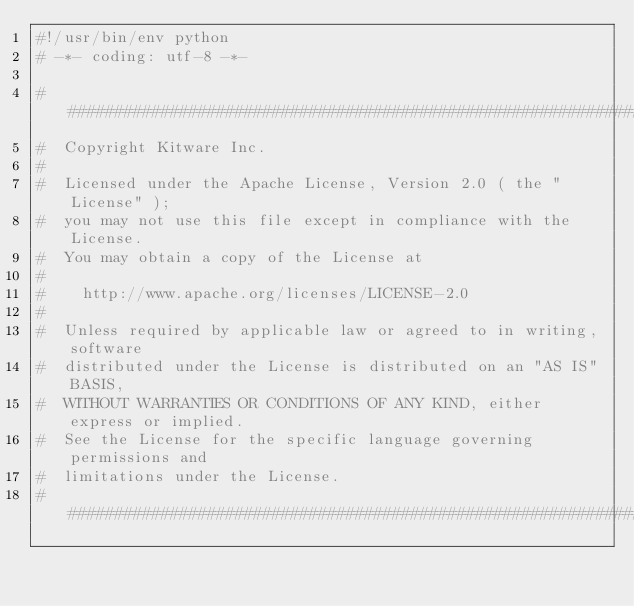<code> <loc_0><loc_0><loc_500><loc_500><_Python_>#!/usr/bin/env python
# -*- coding: utf-8 -*-

###############################################################################
#  Copyright Kitware Inc.
#
#  Licensed under the Apache License, Version 2.0 ( the "License" );
#  you may not use this file except in compliance with the License.
#  You may obtain a copy of the License at
#
#    http://www.apache.org/licenses/LICENSE-2.0
#
#  Unless required by applicable law or agreed to in writing, software
#  distributed under the License is distributed on an "AS IS" BASIS,
#  WITHOUT WARRANTIES OR CONDITIONS OF ANY KIND, either express or implied.
#  See the License for the specific language governing permissions and
#  limitations under the License.
###############################################################################
</code> 